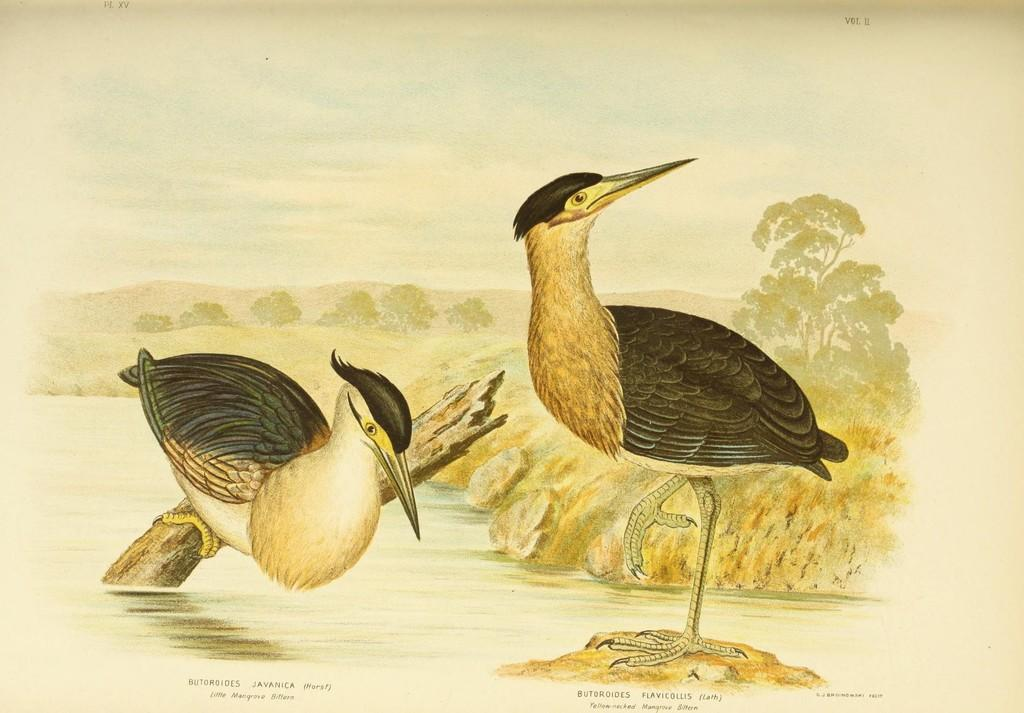What animals are depicted in the painting? There are birds in the painting. What are the birds standing on? The birds are standing on wooden pieces. What is the surface of the wooden pieces resting on? The wooden pieces are on water. What type of road can be seen in the painting? There is a mud road in the painting. What type of vegetation is present in the painting? There are trees in the painting. What geographical feature is visible in the background of the painting? There are mountains in the painting. What type of collar is the bird wearing in the painting? There is no collar present on the birds in the painting. Can you tell me how the birds are talking to each other in the painting? The birds are not talking to each other in the painting, as birds do not have the ability to talk. 